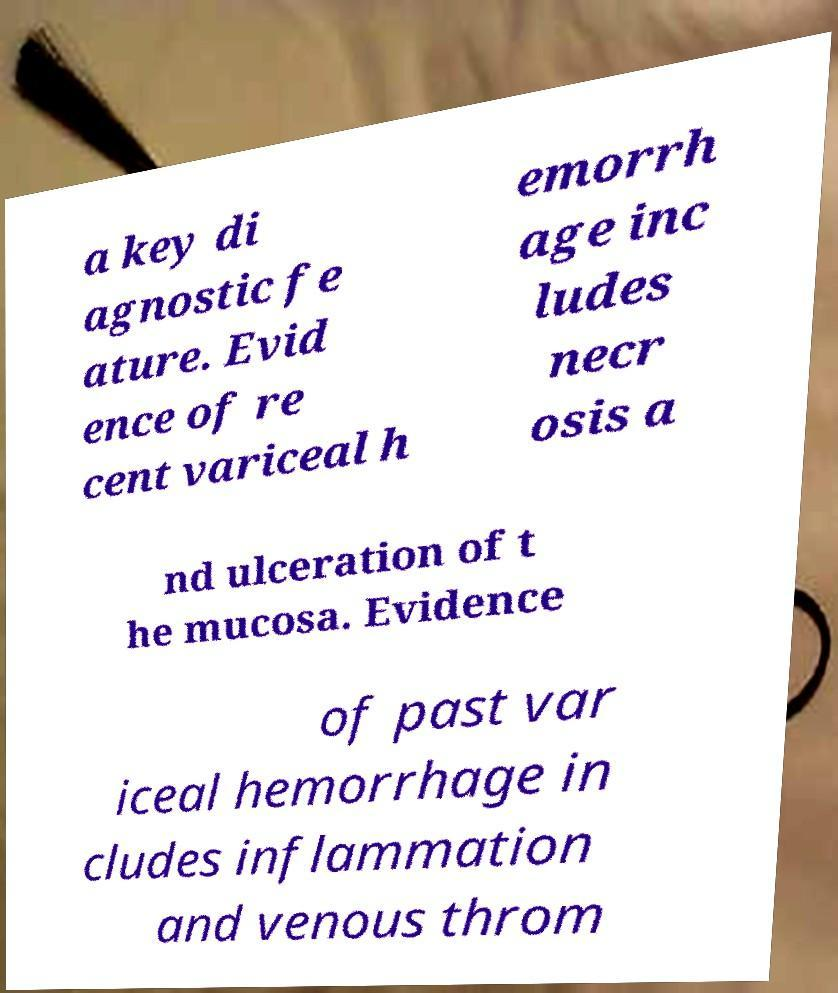Please identify and transcribe the text found in this image. a key di agnostic fe ature. Evid ence of re cent variceal h emorrh age inc ludes necr osis a nd ulceration of t he mucosa. Evidence of past var iceal hemorrhage in cludes inflammation and venous throm 